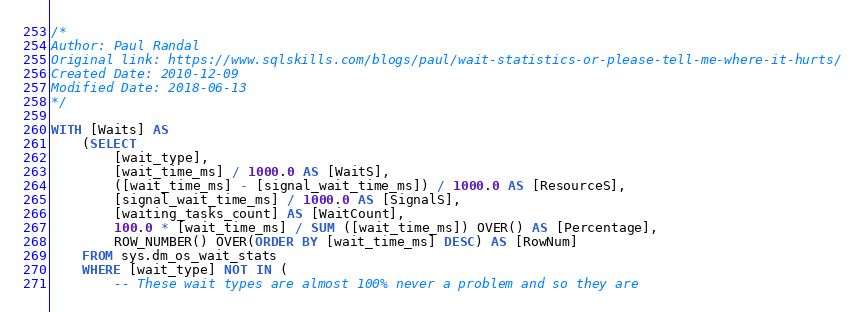Convert code to text. <code><loc_0><loc_0><loc_500><loc_500><_SQL_>/*
Author: Paul Randal
Original link: https://www.sqlskills.com/blogs/paul/wait-statistics-or-please-tell-me-where-it-hurts/
Created Date: 2010-12-09
Modified Date: 2018-06-13
*/

WITH [Waits] AS
    (SELECT
        [wait_type],
        [wait_time_ms] / 1000.0 AS [WaitS],
        ([wait_time_ms] - [signal_wait_time_ms]) / 1000.0 AS [ResourceS],
        [signal_wait_time_ms] / 1000.0 AS [SignalS],
        [waiting_tasks_count] AS [WaitCount],
        100.0 * [wait_time_ms] / SUM ([wait_time_ms]) OVER() AS [Percentage],
        ROW_NUMBER() OVER(ORDER BY [wait_time_ms] DESC) AS [RowNum]
    FROM sys.dm_os_wait_stats
    WHERE [wait_type] NOT IN (
        -- These wait types are almost 100% never a problem and so they are</code> 